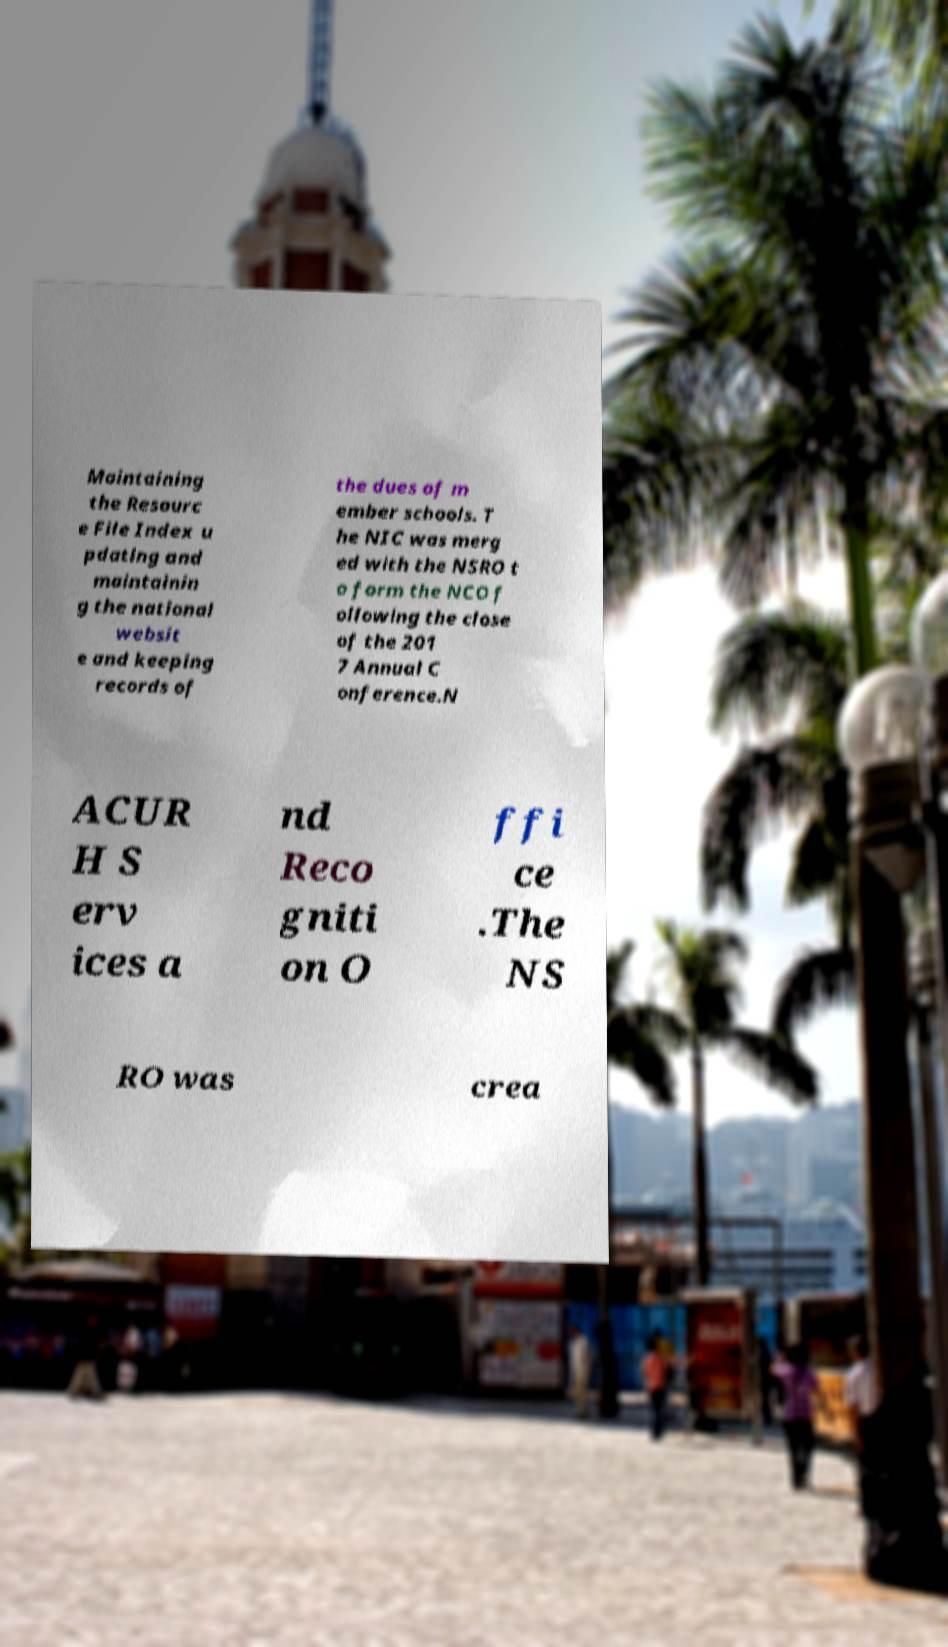For documentation purposes, I need the text within this image transcribed. Could you provide that? Maintaining the Resourc e File Index u pdating and maintainin g the national websit e and keeping records of the dues of m ember schools. T he NIC was merg ed with the NSRO t o form the NCO f ollowing the close of the 201 7 Annual C onference.N ACUR H S erv ices a nd Reco gniti on O ffi ce .The NS RO was crea 